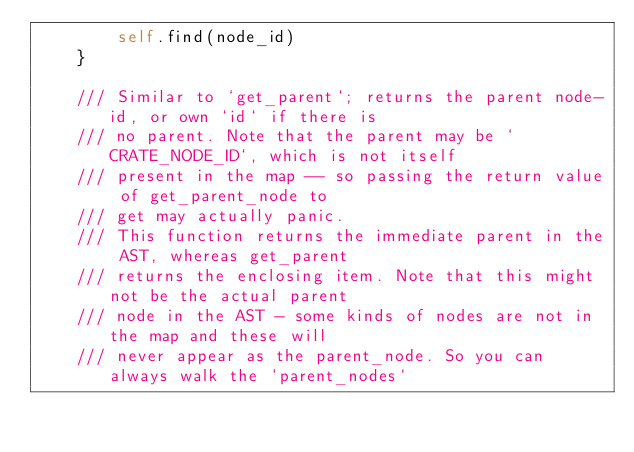Convert code to text. <code><loc_0><loc_0><loc_500><loc_500><_Rust_>        self.find(node_id)
    }

    /// Similar to `get_parent`; returns the parent node-id, or own `id` if there is
    /// no parent. Note that the parent may be `CRATE_NODE_ID`, which is not itself
    /// present in the map -- so passing the return value of get_parent_node to
    /// get may actually panic.
    /// This function returns the immediate parent in the AST, whereas get_parent
    /// returns the enclosing item. Note that this might not be the actual parent
    /// node in the AST - some kinds of nodes are not in the map and these will
    /// never appear as the parent_node. So you can always walk the `parent_nodes`</code> 